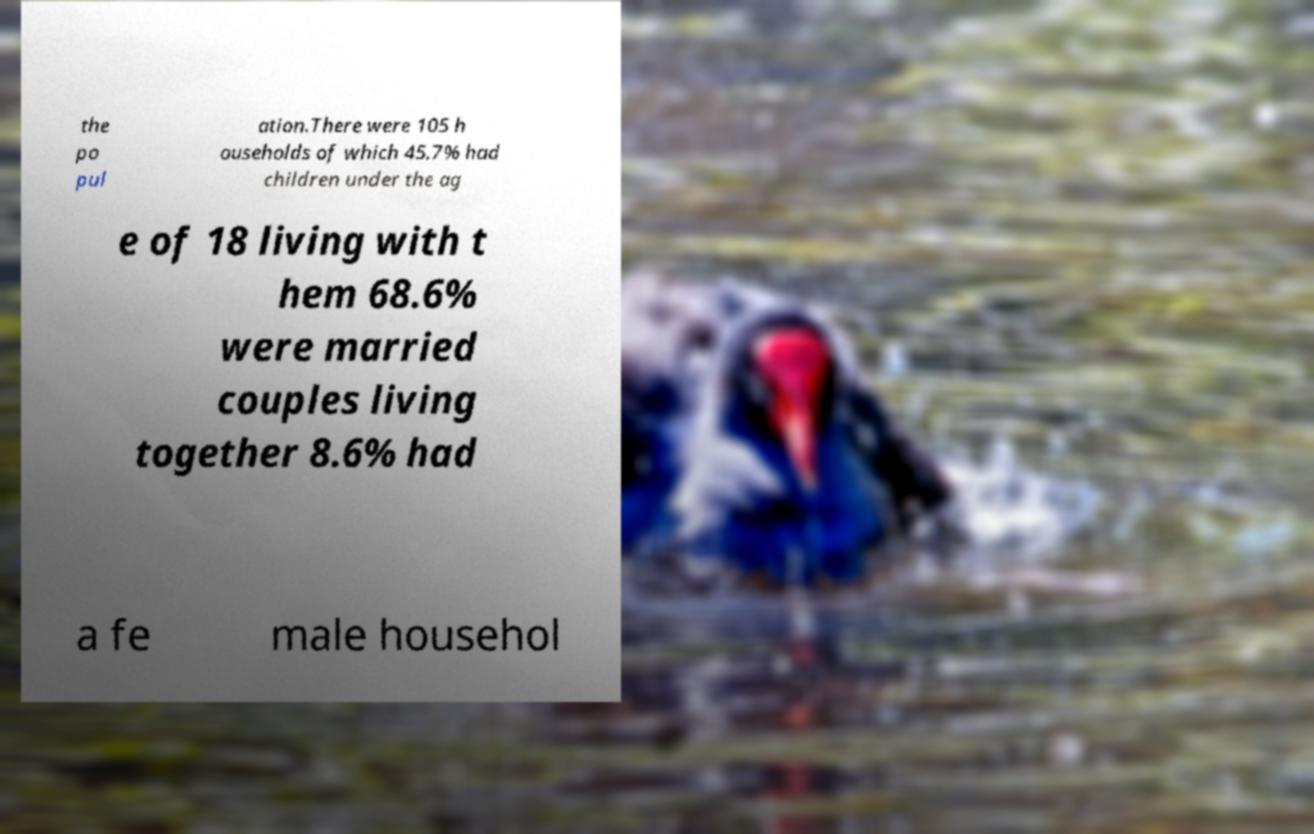For documentation purposes, I need the text within this image transcribed. Could you provide that? the po pul ation.There were 105 h ouseholds of which 45.7% had children under the ag e of 18 living with t hem 68.6% were married couples living together 8.6% had a fe male househol 